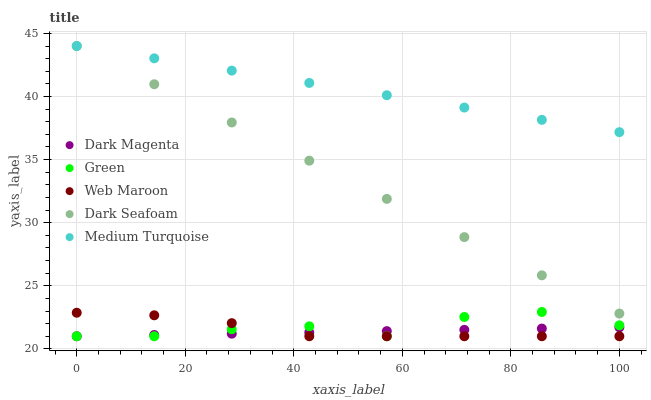Does Dark Magenta have the minimum area under the curve?
Answer yes or no. Yes. Does Medium Turquoise have the maximum area under the curve?
Answer yes or no. Yes. Does Dark Seafoam have the minimum area under the curve?
Answer yes or no. No. Does Dark Seafoam have the maximum area under the curve?
Answer yes or no. No. Is Dark Seafoam the smoothest?
Answer yes or no. Yes. Is Green the roughest?
Answer yes or no. Yes. Is Green the smoothest?
Answer yes or no. No. Is Dark Seafoam the roughest?
Answer yes or no. No. Does Web Maroon have the lowest value?
Answer yes or no. Yes. Does Dark Seafoam have the lowest value?
Answer yes or no. No. Does Medium Turquoise have the highest value?
Answer yes or no. Yes. Does Green have the highest value?
Answer yes or no. No. Is Green less than Dark Seafoam?
Answer yes or no. Yes. Is Medium Turquoise greater than Green?
Answer yes or no. Yes. Does Medium Turquoise intersect Dark Seafoam?
Answer yes or no. Yes. Is Medium Turquoise less than Dark Seafoam?
Answer yes or no. No. Is Medium Turquoise greater than Dark Seafoam?
Answer yes or no. No. Does Green intersect Dark Seafoam?
Answer yes or no. No. 